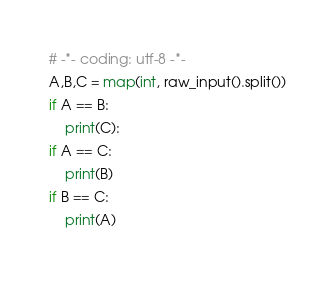<code> <loc_0><loc_0><loc_500><loc_500><_Python_># -*- coding: utf-8 -*-
A,B,C = map(int, raw_input().split())
if A == B:
    print(C):
if A == C:
    print(B)
if B == C:
    print(A)
</code> 